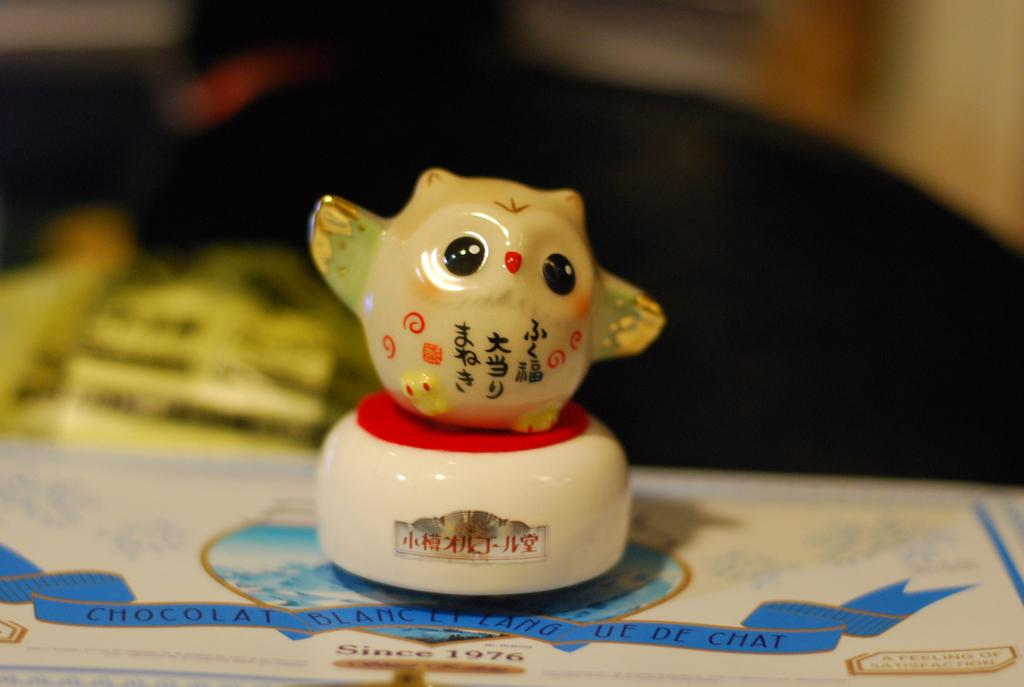What object can be seen in the image? There is a toy in the image. Can you describe the background of the image? The background of the image is blurred. Where is the daughter holding the mitten in the image? There is no daughter or mitten present in the image; it only features a toy and a blurred background. 